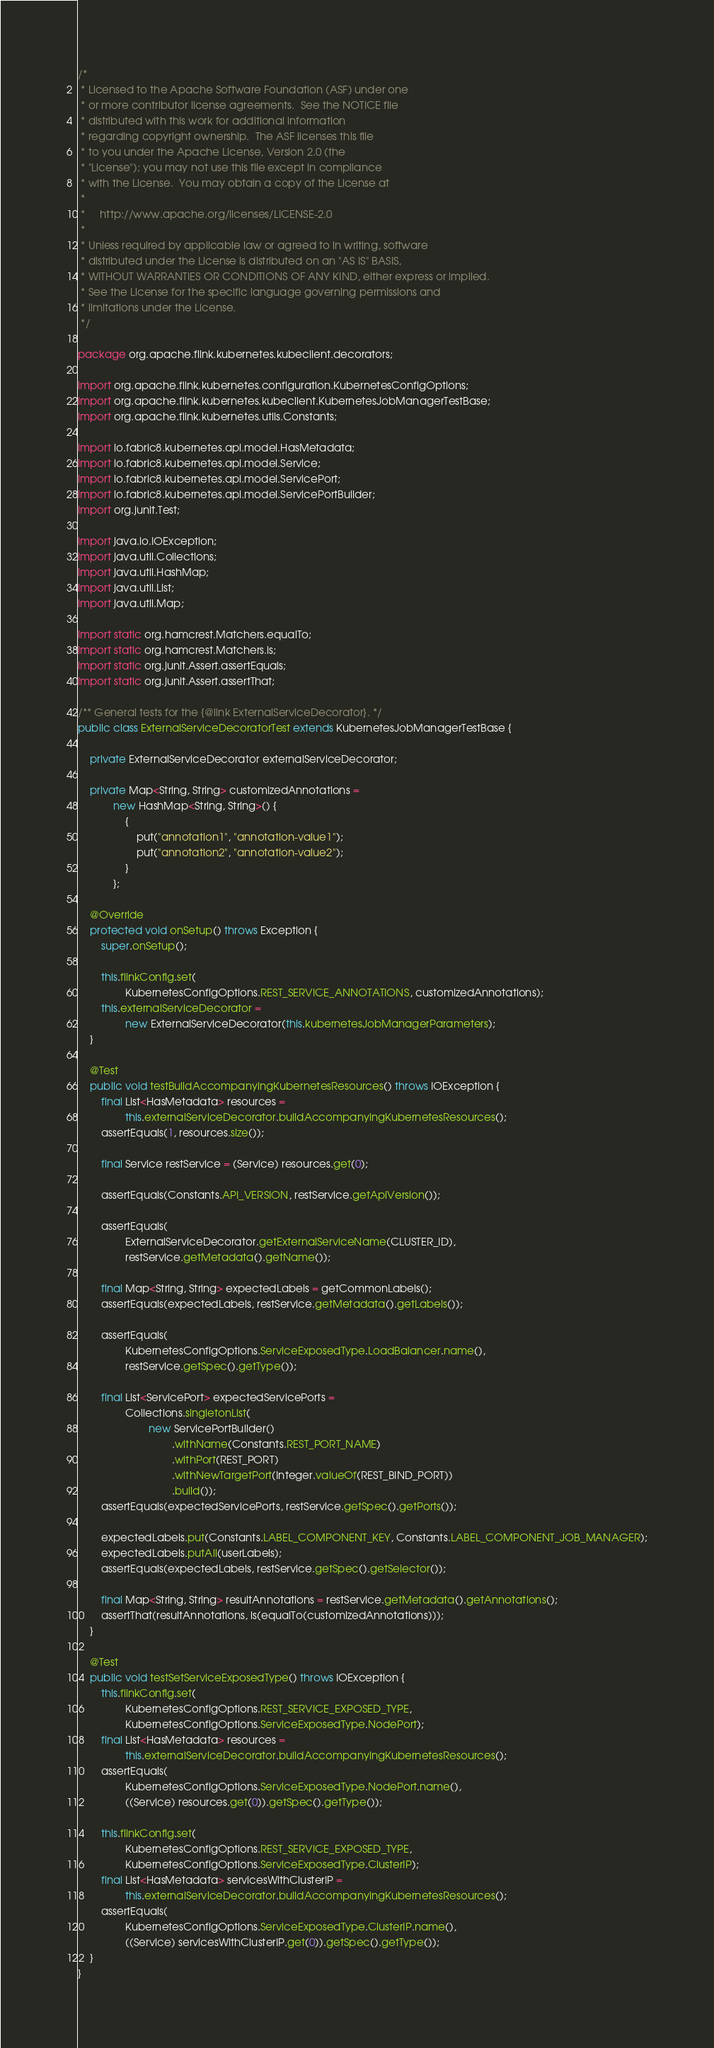<code> <loc_0><loc_0><loc_500><loc_500><_Java_>/*
 * Licensed to the Apache Software Foundation (ASF) under one
 * or more contributor license agreements.  See the NOTICE file
 * distributed with this work for additional information
 * regarding copyright ownership.  The ASF licenses this file
 * to you under the Apache License, Version 2.0 (the
 * "License"); you may not use this file except in compliance
 * with the License.  You may obtain a copy of the License at
 *
 *     http://www.apache.org/licenses/LICENSE-2.0
 *
 * Unless required by applicable law or agreed to in writing, software
 * distributed under the License is distributed on an "AS IS" BASIS,
 * WITHOUT WARRANTIES OR CONDITIONS OF ANY KIND, either express or implied.
 * See the License for the specific language governing permissions and
 * limitations under the License.
 */

package org.apache.flink.kubernetes.kubeclient.decorators;

import org.apache.flink.kubernetes.configuration.KubernetesConfigOptions;
import org.apache.flink.kubernetes.kubeclient.KubernetesJobManagerTestBase;
import org.apache.flink.kubernetes.utils.Constants;

import io.fabric8.kubernetes.api.model.HasMetadata;
import io.fabric8.kubernetes.api.model.Service;
import io.fabric8.kubernetes.api.model.ServicePort;
import io.fabric8.kubernetes.api.model.ServicePortBuilder;
import org.junit.Test;

import java.io.IOException;
import java.util.Collections;
import java.util.HashMap;
import java.util.List;
import java.util.Map;

import static org.hamcrest.Matchers.equalTo;
import static org.hamcrest.Matchers.is;
import static org.junit.Assert.assertEquals;
import static org.junit.Assert.assertThat;

/** General tests for the {@link ExternalServiceDecorator}. */
public class ExternalServiceDecoratorTest extends KubernetesJobManagerTestBase {

    private ExternalServiceDecorator externalServiceDecorator;

    private Map<String, String> customizedAnnotations =
            new HashMap<String, String>() {
                {
                    put("annotation1", "annotation-value1");
                    put("annotation2", "annotation-value2");
                }
            };

    @Override
    protected void onSetup() throws Exception {
        super.onSetup();

        this.flinkConfig.set(
                KubernetesConfigOptions.REST_SERVICE_ANNOTATIONS, customizedAnnotations);
        this.externalServiceDecorator =
                new ExternalServiceDecorator(this.kubernetesJobManagerParameters);
    }

    @Test
    public void testBuildAccompanyingKubernetesResources() throws IOException {
        final List<HasMetadata> resources =
                this.externalServiceDecorator.buildAccompanyingKubernetesResources();
        assertEquals(1, resources.size());

        final Service restService = (Service) resources.get(0);

        assertEquals(Constants.API_VERSION, restService.getApiVersion());

        assertEquals(
                ExternalServiceDecorator.getExternalServiceName(CLUSTER_ID),
                restService.getMetadata().getName());

        final Map<String, String> expectedLabels = getCommonLabels();
        assertEquals(expectedLabels, restService.getMetadata().getLabels());

        assertEquals(
                KubernetesConfigOptions.ServiceExposedType.LoadBalancer.name(),
                restService.getSpec().getType());

        final List<ServicePort> expectedServicePorts =
                Collections.singletonList(
                        new ServicePortBuilder()
                                .withName(Constants.REST_PORT_NAME)
                                .withPort(REST_PORT)
                                .withNewTargetPort(Integer.valueOf(REST_BIND_PORT))
                                .build());
        assertEquals(expectedServicePorts, restService.getSpec().getPorts());

        expectedLabels.put(Constants.LABEL_COMPONENT_KEY, Constants.LABEL_COMPONENT_JOB_MANAGER);
        expectedLabels.putAll(userLabels);
        assertEquals(expectedLabels, restService.getSpec().getSelector());

        final Map<String, String> resultAnnotations = restService.getMetadata().getAnnotations();
        assertThat(resultAnnotations, is(equalTo(customizedAnnotations)));
    }

    @Test
    public void testSetServiceExposedType() throws IOException {
        this.flinkConfig.set(
                KubernetesConfigOptions.REST_SERVICE_EXPOSED_TYPE,
                KubernetesConfigOptions.ServiceExposedType.NodePort);
        final List<HasMetadata> resources =
                this.externalServiceDecorator.buildAccompanyingKubernetesResources();
        assertEquals(
                KubernetesConfigOptions.ServiceExposedType.NodePort.name(),
                ((Service) resources.get(0)).getSpec().getType());

        this.flinkConfig.set(
                KubernetesConfigOptions.REST_SERVICE_EXPOSED_TYPE,
                KubernetesConfigOptions.ServiceExposedType.ClusterIP);
        final List<HasMetadata> servicesWithClusterIP =
                this.externalServiceDecorator.buildAccompanyingKubernetesResources();
        assertEquals(
                KubernetesConfigOptions.ServiceExposedType.ClusterIP.name(),
                ((Service) servicesWithClusterIP.get(0)).getSpec().getType());
    }
}
</code> 